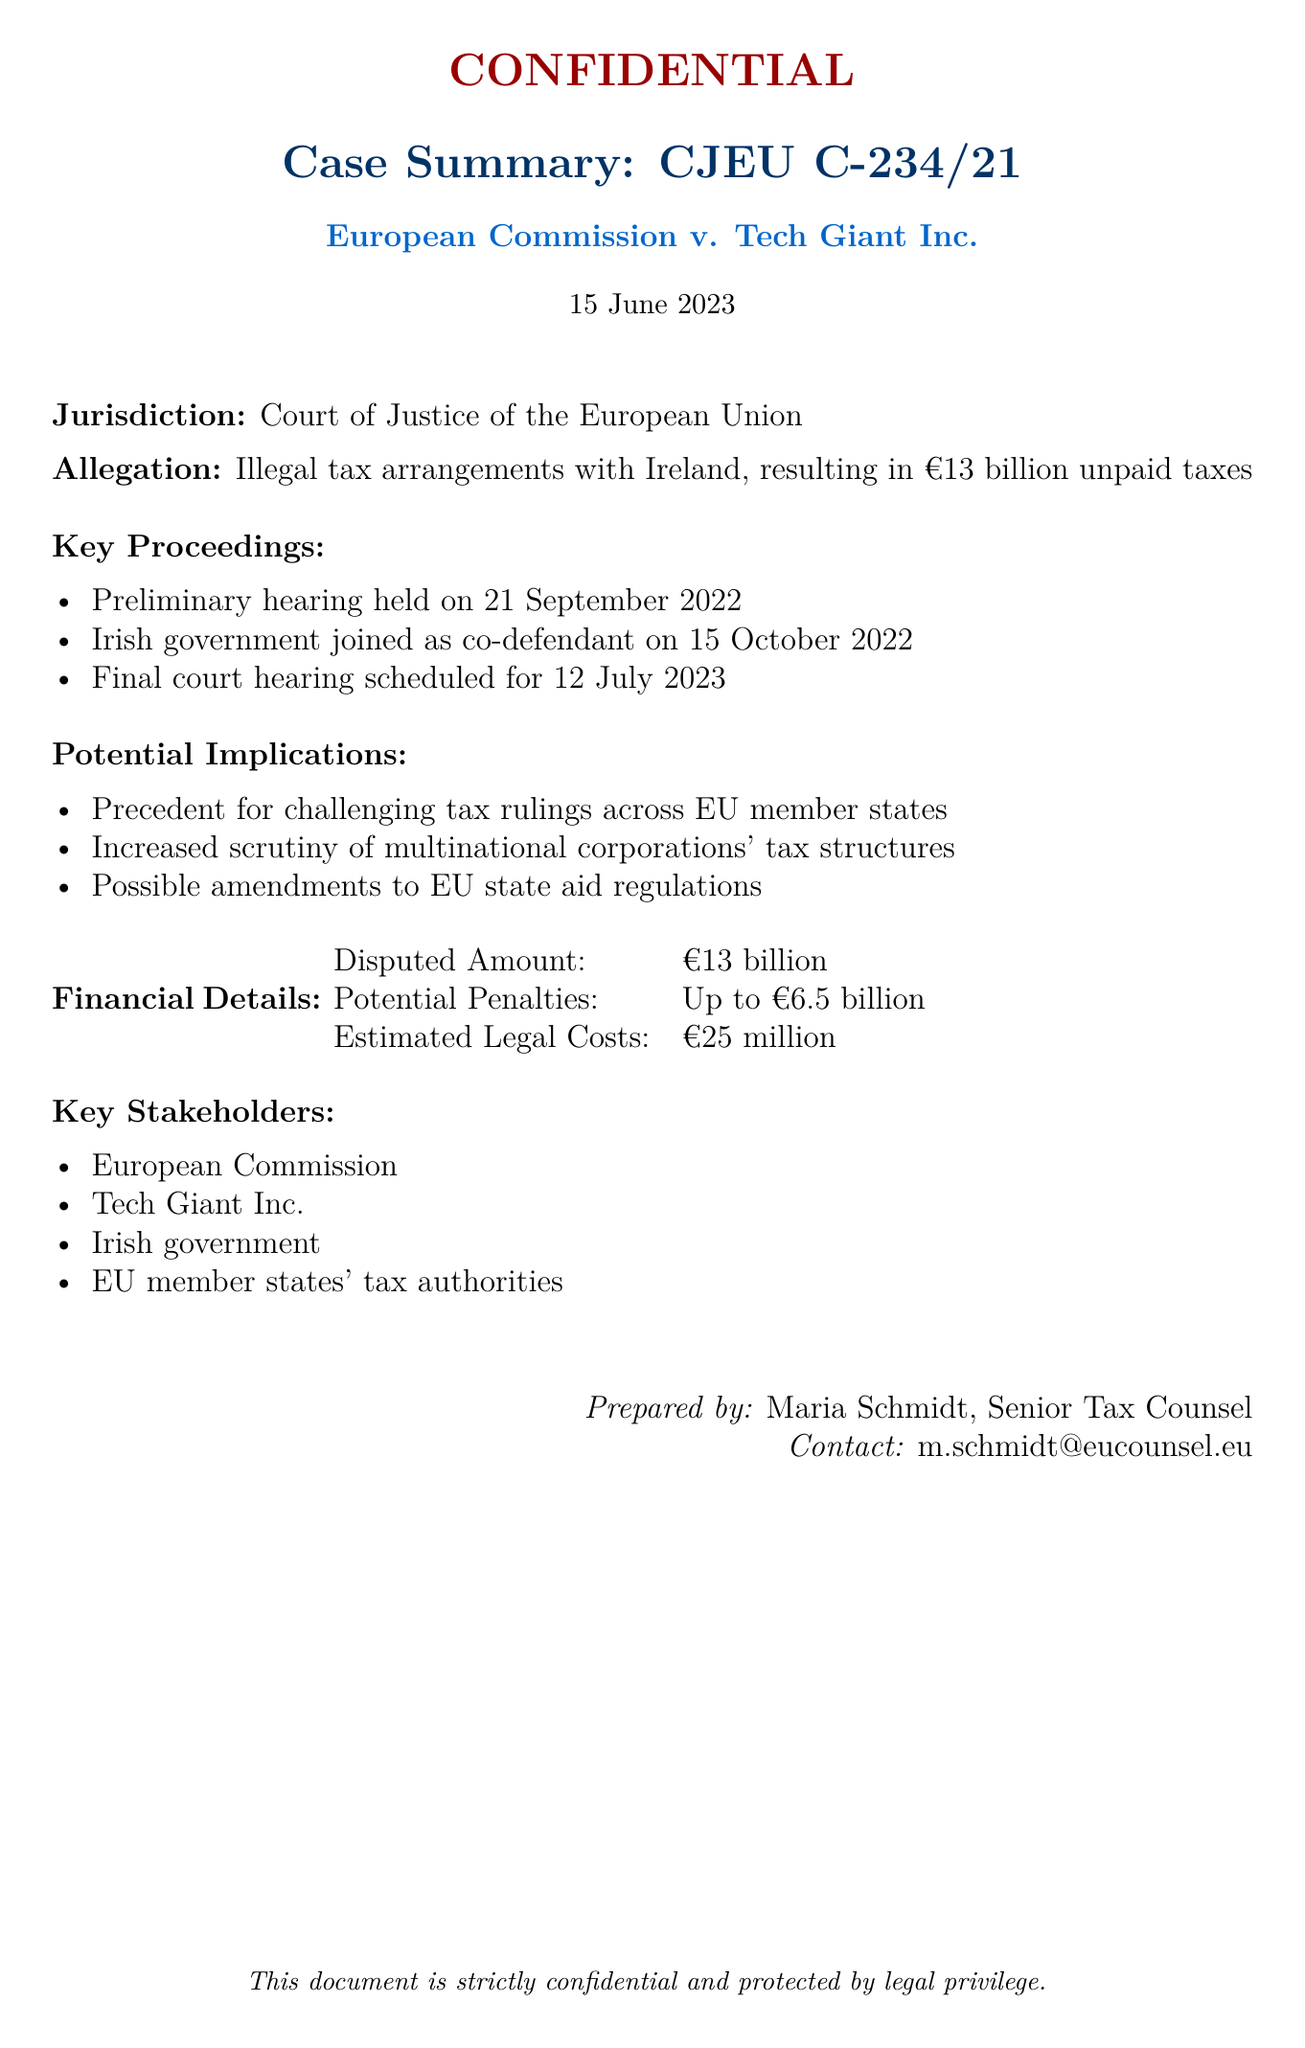What is the jurisdiction of the case? The jurisdiction refers to the court that is handling the case, which is stated as the Court of Justice of the European Union.
Answer: Court of Justice of the European Union What is the dispute amount in the case? The dispute amount is a specific financial figure highlighted in the document.
Answer: €13 billion When was the final court hearing scheduled? The date of the final court hearing is explicitly mentioned in the document.
Answer: 12 July 2023 Who joined as a co-defendant? The document specifies that the Irish government was involved as a co-defendant, offering key context regarding the case's participants.
Answer: Irish government What is the potential maximum penalty mentioned? The maximum penalty is noted in the financial details section of the document, directly indicating the potential financial consequences for Tech Giant Inc.
Answer: Up to €6.5 billion What could be a possible implication of the case? The implications are listed in the document, where multiple potential outcomes are suggested based on the case proceedings.
Answer: Increased scrutiny of multinational corporations' tax structures What date was the preliminary hearing held? The specific date of the preliminary hearing is mentioned within the proceeding details of the document.
Answer: 21 September 2022 Who prepared the summary document? The document indicates the person responsible for its preparation, highlighting the author's affiliation and role.
Answer: Maria Schmidt, Senior Tax Counsel 